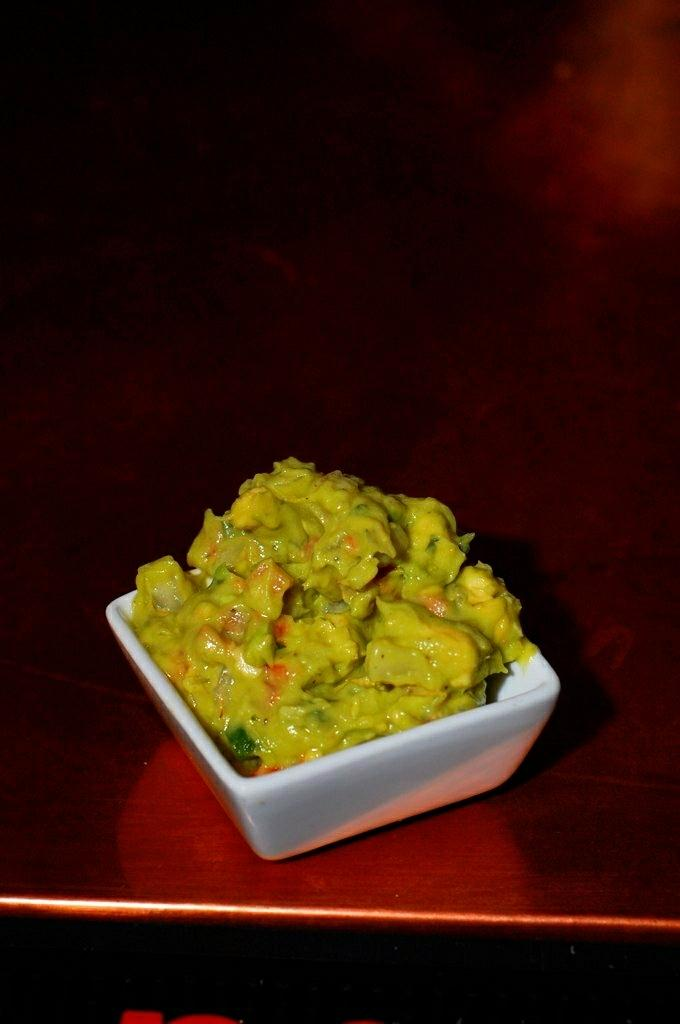What is the main subject in the center of the image? There is food in a bowl in the center of the image. What is located at the bottom of the image? There is a table at the bottom of the image. Where is the jail located in the image? There is no jail present in the image. How many babies are visible in the image? There are no babies present in the image. 